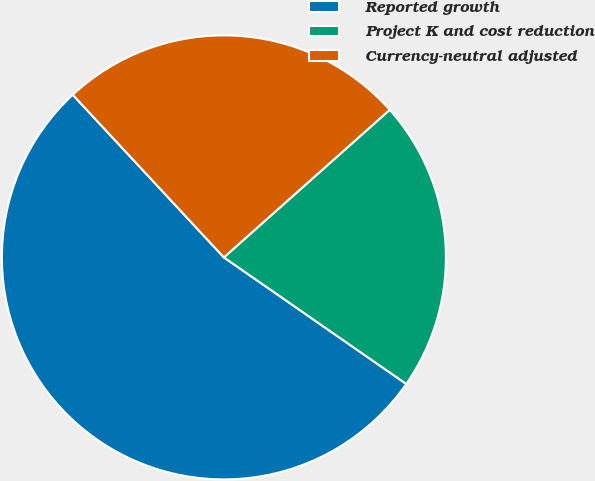<chart> <loc_0><loc_0><loc_500><loc_500><pie_chart><fcel>Reported growth<fcel>Project K and cost reduction<fcel>Currency-neutral adjusted<nl><fcel>53.42%<fcel>21.23%<fcel>25.34%<nl></chart> 